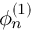<formula> <loc_0><loc_0><loc_500><loc_500>\phi _ { n } ^ { ( 1 ) }</formula> 